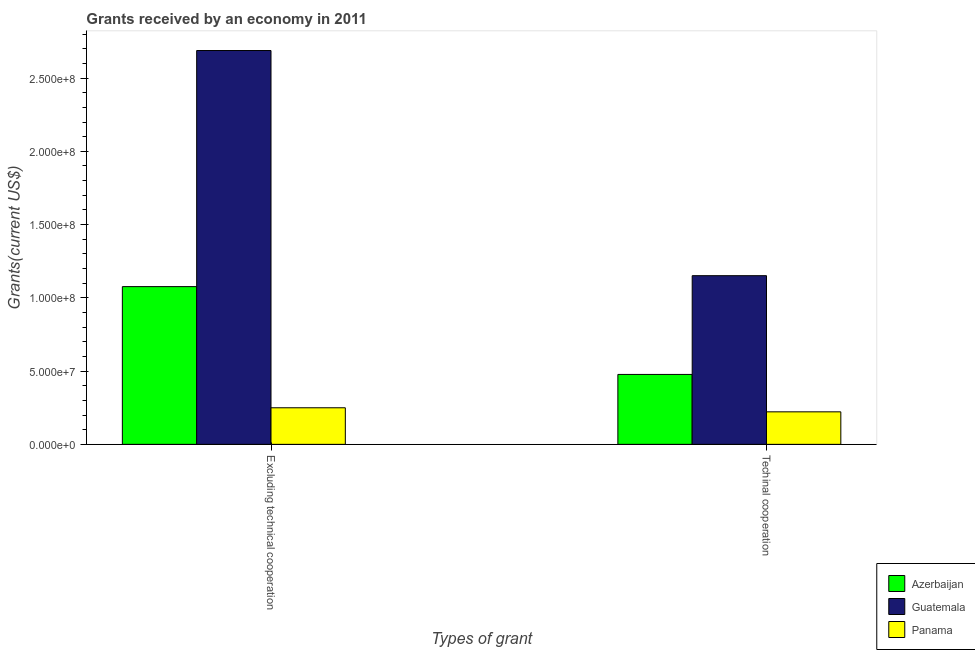How many groups of bars are there?
Your answer should be very brief. 2. What is the label of the 1st group of bars from the left?
Your answer should be compact. Excluding technical cooperation. What is the amount of grants received(including technical cooperation) in Guatemala?
Offer a terse response. 1.15e+08. Across all countries, what is the maximum amount of grants received(including technical cooperation)?
Your answer should be compact. 1.15e+08. Across all countries, what is the minimum amount of grants received(excluding technical cooperation)?
Offer a very short reply. 2.50e+07. In which country was the amount of grants received(including technical cooperation) maximum?
Provide a short and direct response. Guatemala. In which country was the amount of grants received(including technical cooperation) minimum?
Ensure brevity in your answer.  Panama. What is the total amount of grants received(excluding technical cooperation) in the graph?
Your answer should be compact. 4.01e+08. What is the difference between the amount of grants received(excluding technical cooperation) in Azerbaijan and that in Panama?
Offer a terse response. 8.27e+07. What is the difference between the amount of grants received(including technical cooperation) in Azerbaijan and the amount of grants received(excluding technical cooperation) in Guatemala?
Make the answer very short. -2.21e+08. What is the average amount of grants received(excluding technical cooperation) per country?
Provide a succinct answer. 1.34e+08. What is the difference between the amount of grants received(including technical cooperation) and amount of grants received(excluding technical cooperation) in Panama?
Your answer should be very brief. -2.77e+06. In how many countries, is the amount of grants received(excluding technical cooperation) greater than 90000000 US$?
Offer a terse response. 2. What is the ratio of the amount of grants received(excluding technical cooperation) in Azerbaijan to that in Panama?
Keep it short and to the point. 4.31. What does the 1st bar from the left in Excluding technical cooperation represents?
Provide a succinct answer. Azerbaijan. What does the 3rd bar from the right in Techinal cooperation represents?
Make the answer very short. Azerbaijan. Are all the bars in the graph horizontal?
Provide a succinct answer. No. How many countries are there in the graph?
Keep it short and to the point. 3. Does the graph contain grids?
Your answer should be very brief. No. What is the title of the graph?
Give a very brief answer. Grants received by an economy in 2011. Does "Tunisia" appear as one of the legend labels in the graph?
Provide a short and direct response. No. What is the label or title of the X-axis?
Offer a terse response. Types of grant. What is the label or title of the Y-axis?
Provide a short and direct response. Grants(current US$). What is the Grants(current US$) of Azerbaijan in Excluding technical cooperation?
Provide a succinct answer. 1.08e+08. What is the Grants(current US$) of Guatemala in Excluding technical cooperation?
Make the answer very short. 2.69e+08. What is the Grants(current US$) in Panama in Excluding technical cooperation?
Make the answer very short. 2.50e+07. What is the Grants(current US$) in Azerbaijan in Techinal cooperation?
Give a very brief answer. 4.77e+07. What is the Grants(current US$) of Guatemala in Techinal cooperation?
Offer a terse response. 1.15e+08. What is the Grants(current US$) of Panama in Techinal cooperation?
Ensure brevity in your answer.  2.22e+07. Across all Types of grant, what is the maximum Grants(current US$) in Azerbaijan?
Ensure brevity in your answer.  1.08e+08. Across all Types of grant, what is the maximum Grants(current US$) of Guatemala?
Make the answer very short. 2.69e+08. Across all Types of grant, what is the maximum Grants(current US$) in Panama?
Provide a short and direct response. 2.50e+07. Across all Types of grant, what is the minimum Grants(current US$) of Azerbaijan?
Make the answer very short. 4.77e+07. Across all Types of grant, what is the minimum Grants(current US$) in Guatemala?
Your answer should be very brief. 1.15e+08. Across all Types of grant, what is the minimum Grants(current US$) of Panama?
Ensure brevity in your answer.  2.22e+07. What is the total Grants(current US$) in Azerbaijan in the graph?
Your answer should be very brief. 1.55e+08. What is the total Grants(current US$) of Guatemala in the graph?
Provide a succinct answer. 3.84e+08. What is the total Grants(current US$) in Panama in the graph?
Offer a terse response. 4.72e+07. What is the difference between the Grants(current US$) of Azerbaijan in Excluding technical cooperation and that in Techinal cooperation?
Your answer should be compact. 5.99e+07. What is the difference between the Grants(current US$) in Guatemala in Excluding technical cooperation and that in Techinal cooperation?
Provide a short and direct response. 1.54e+08. What is the difference between the Grants(current US$) in Panama in Excluding technical cooperation and that in Techinal cooperation?
Your answer should be very brief. 2.77e+06. What is the difference between the Grants(current US$) of Azerbaijan in Excluding technical cooperation and the Grants(current US$) of Guatemala in Techinal cooperation?
Your answer should be compact. -7.46e+06. What is the difference between the Grants(current US$) in Azerbaijan in Excluding technical cooperation and the Grants(current US$) in Panama in Techinal cooperation?
Provide a succinct answer. 8.55e+07. What is the difference between the Grants(current US$) of Guatemala in Excluding technical cooperation and the Grants(current US$) of Panama in Techinal cooperation?
Your answer should be very brief. 2.47e+08. What is the average Grants(current US$) of Azerbaijan per Types of grant?
Keep it short and to the point. 7.77e+07. What is the average Grants(current US$) in Guatemala per Types of grant?
Provide a succinct answer. 1.92e+08. What is the average Grants(current US$) of Panama per Types of grant?
Provide a succinct answer. 2.36e+07. What is the difference between the Grants(current US$) in Azerbaijan and Grants(current US$) in Guatemala in Excluding technical cooperation?
Your response must be concise. -1.61e+08. What is the difference between the Grants(current US$) of Azerbaijan and Grants(current US$) of Panama in Excluding technical cooperation?
Your response must be concise. 8.27e+07. What is the difference between the Grants(current US$) of Guatemala and Grants(current US$) of Panama in Excluding technical cooperation?
Your response must be concise. 2.44e+08. What is the difference between the Grants(current US$) in Azerbaijan and Grants(current US$) in Guatemala in Techinal cooperation?
Your response must be concise. -6.74e+07. What is the difference between the Grants(current US$) in Azerbaijan and Grants(current US$) in Panama in Techinal cooperation?
Offer a terse response. 2.55e+07. What is the difference between the Grants(current US$) in Guatemala and Grants(current US$) in Panama in Techinal cooperation?
Ensure brevity in your answer.  9.29e+07. What is the ratio of the Grants(current US$) of Azerbaijan in Excluding technical cooperation to that in Techinal cooperation?
Your answer should be very brief. 2.26. What is the ratio of the Grants(current US$) in Guatemala in Excluding technical cooperation to that in Techinal cooperation?
Provide a short and direct response. 2.33. What is the ratio of the Grants(current US$) in Panama in Excluding technical cooperation to that in Techinal cooperation?
Provide a short and direct response. 1.12. What is the difference between the highest and the second highest Grants(current US$) of Azerbaijan?
Keep it short and to the point. 5.99e+07. What is the difference between the highest and the second highest Grants(current US$) in Guatemala?
Make the answer very short. 1.54e+08. What is the difference between the highest and the second highest Grants(current US$) in Panama?
Your answer should be compact. 2.77e+06. What is the difference between the highest and the lowest Grants(current US$) in Azerbaijan?
Your answer should be very brief. 5.99e+07. What is the difference between the highest and the lowest Grants(current US$) in Guatemala?
Provide a succinct answer. 1.54e+08. What is the difference between the highest and the lowest Grants(current US$) of Panama?
Keep it short and to the point. 2.77e+06. 